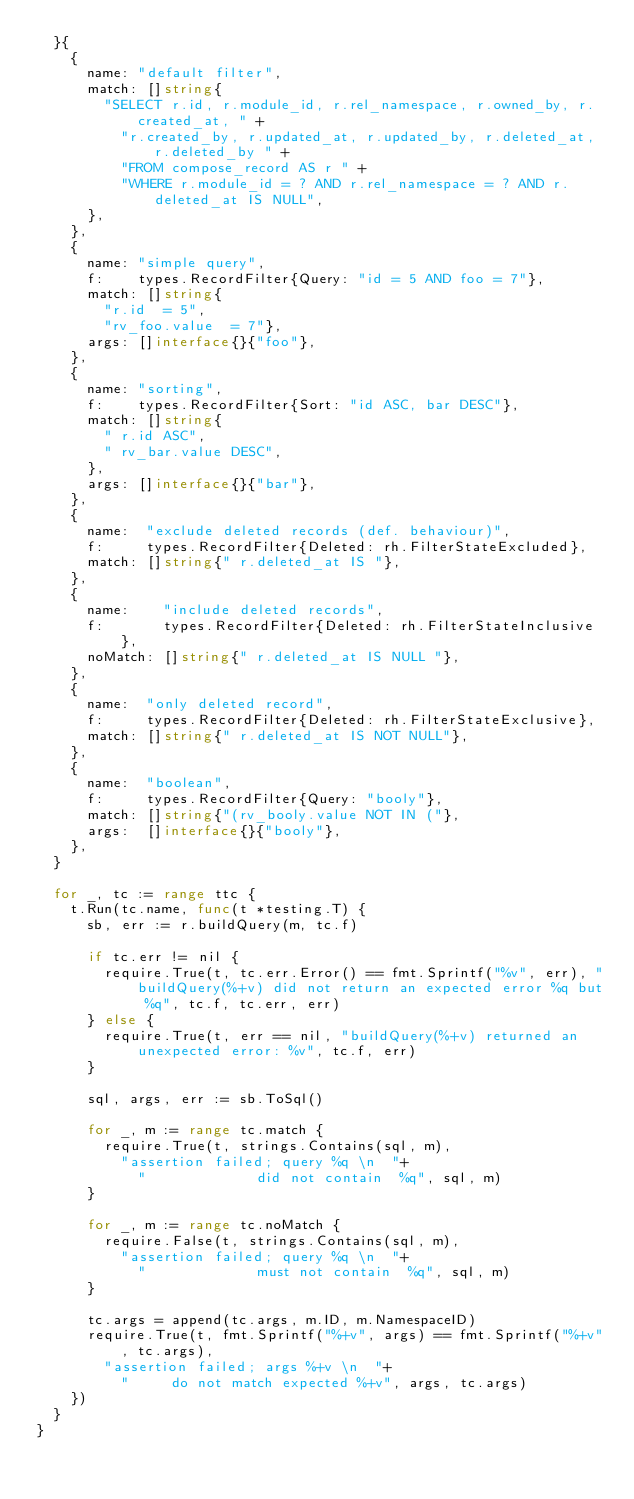Convert code to text. <code><loc_0><loc_0><loc_500><loc_500><_Go_>	}{
		{
			name: "default filter",
			match: []string{
				"SELECT r.id, r.module_id, r.rel_namespace, r.owned_by, r.created_at, " +
					"r.created_by, r.updated_at, r.updated_by, r.deleted_at, r.deleted_by " +
					"FROM compose_record AS r " +
					"WHERE r.module_id = ? AND r.rel_namespace = ? AND r.deleted_at IS NULL",
			},
		},
		{
			name: "simple query",
			f:    types.RecordFilter{Query: "id = 5 AND foo = 7"},
			match: []string{
				"r.id  = 5",
				"rv_foo.value  = 7"},
			args: []interface{}{"foo"},
		},
		{
			name: "sorting",
			f:    types.RecordFilter{Sort: "id ASC, bar DESC"},
			match: []string{
				" r.id ASC",
				" rv_bar.value DESC",
			},
			args: []interface{}{"bar"},
		},
		{
			name:  "exclude deleted records (def. behaviour)",
			f:     types.RecordFilter{Deleted: rh.FilterStateExcluded},
			match: []string{" r.deleted_at IS "},
		},
		{
			name:    "include deleted records",
			f:       types.RecordFilter{Deleted: rh.FilterStateInclusive},
			noMatch: []string{" r.deleted_at IS NULL "},
		},
		{
			name:  "only deleted record",
			f:     types.RecordFilter{Deleted: rh.FilterStateExclusive},
			match: []string{" r.deleted_at IS NOT NULL"},
		},
		{
			name:  "boolean",
			f:     types.RecordFilter{Query: "booly"},
			match: []string{"(rv_booly.value NOT IN ("},
			args:  []interface{}{"booly"},
		},
	}

	for _, tc := range ttc {
		t.Run(tc.name, func(t *testing.T) {
			sb, err := r.buildQuery(m, tc.f)

			if tc.err != nil {
				require.True(t, tc.err.Error() == fmt.Sprintf("%v", err), "buildQuery(%+v) did not return an expected error %q but %q", tc.f, tc.err, err)
			} else {
				require.True(t, err == nil, "buildQuery(%+v) returned an unexpected error: %v", tc.f, err)
			}

			sql, args, err := sb.ToSql()

			for _, m := range tc.match {
				require.True(t, strings.Contains(sql, m),
					"assertion failed; query %q \n  "+
						"             did not contain  %q", sql, m)
			}

			for _, m := range tc.noMatch {
				require.False(t, strings.Contains(sql, m),
					"assertion failed; query %q \n  "+
						"             must not contain  %q", sql, m)
			}

			tc.args = append(tc.args, m.ID, m.NamespaceID)
			require.True(t, fmt.Sprintf("%+v", args) == fmt.Sprintf("%+v", tc.args),
				"assertion failed; args %+v \n  "+
					"     do not match expected %+v", args, tc.args)
		})
	}
}
</code> 